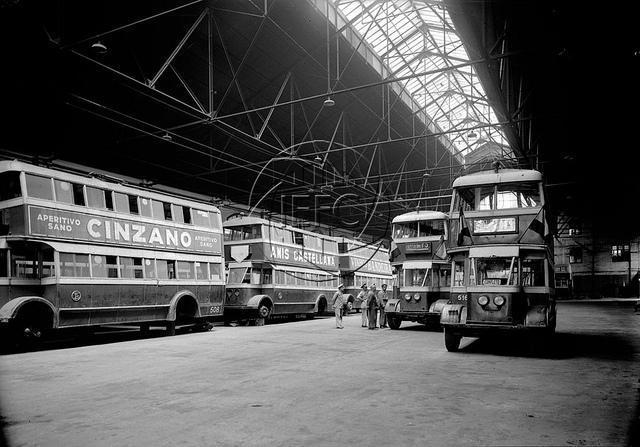How many trucks are in this garage?
Give a very brief answer. 5. How many buses are in the picture?
Give a very brief answer. 4. 